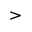Convert formula to latex. <formula><loc_0><loc_0><loc_500><loc_500>></formula> 